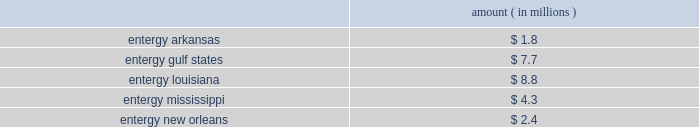Domestic utility companies and system energy notes to respective financial statements protested the disallowance of these deductions to the office of irs appeals .
Entergy expects to receive a notice of deficiency in 2005 for this item , and plans to vigorously contest this matter .
Entergy believes that the contingency provision established in its financial statements sufficiently covers the risk associated with this item .
Mark to market of certain power contracts in 2001 , entergy louisiana changed its method of accounting for tax purposes related to its wholesale electric power contracts .
The most significant of these is the contract to purchase power from the vidalia hydroelectric project .
The new tax accounting method has provided a cumulative cash flow benefit of approximately $ 790 million as of december 31 , 2004 .
The related irs interest exposure is $ 93 million at december 31 , 2004 .
This benefit is expected to reverse in the years 2005 through 2031 .
The election did not reduce book income tax expense .
The timing of the reversal of this benefit depends on several variables , including the price of power .
Due to the temporary nature of the tax benefit , the potential interest charge represents entergy's net earnings exposure .
Entergy louisiana's 2001 tax return is currently under examination by the irs , though no adjustments have yet been proposed with respect to the mark to market election .
Entergy believes that the contingency provision established in its financial statements will sufficiently cover the risk associated with this issue .
Cashpoint bankruptcy ( entergy arkansas , entergy gulf states , entergy louisiana , entergy mississippi , and entergy new orleans ) in 2003 the domestic utility companies entered an agreement with cashpoint network services ( cashpoint ) under which cashpoint was to manage a network of payment agents through which entergy's utility customers could pay their bills .
The payment agent system allows customers to pay their bills at various commercial or governmental locations , rather than sending payments by mail .
Approximately one-third of entergy's utility customers use payment agents .
On april 19 , 2004 , cashpoint failed to pay funds due to the domestic utility companies that had been collected through payment agents .
The domestic utility companies then obtained a temporary restraining order from the civil district court for the parish of orleans , state of louisiana , enjoining cashpoint from distributing funds belonging to entergy , except by paying those funds to entergy .
On april 22 , 2004 , a petition for involuntary chapter 7 bankruptcy was filed against cashpoint by other creditors in the united states bankruptcy court for the southern district of new york .
In response to these events , the domestic utility companies expanded an existing contract with another company to manage all of their payment agents .
The domestic utility companies filed proofs of claim in the cashpoint bankruptcy proceeding in september 2004 .
Although entergy cannot precisely determine at this time the amount that cashpoint owes to the domestic utility companies that may not be repaid , it has accrued an estimate of loss based on current information .
If no cash is repaid to the domestic utility companies , an event entergy does not believe is likely , the current estimates of maximum exposure to loss are approximately as follows : amount ( in millions ) .
Environmental issues ( entergy gulf states ) entergy gulf states has been designated as a prp for the cleanup of certain hazardous waste disposal sites .
As of december 31 , 2004 , entergy gulf states does not expect the remaining clean-up costs to exceed its recorded liability of $ 1.5 million for the remaining sites at which the epa has designated entergy gulf states as a prp. .
What portion of the maximum exposure to loss for entergy if no cash is repaid to domestic utility companies is incurred from entergy louisiana? 
Computations: (8.8 / ((((1.8 + 7.7) + 8.8) + 4.3) + 2.4))
Answer: 0.352. 